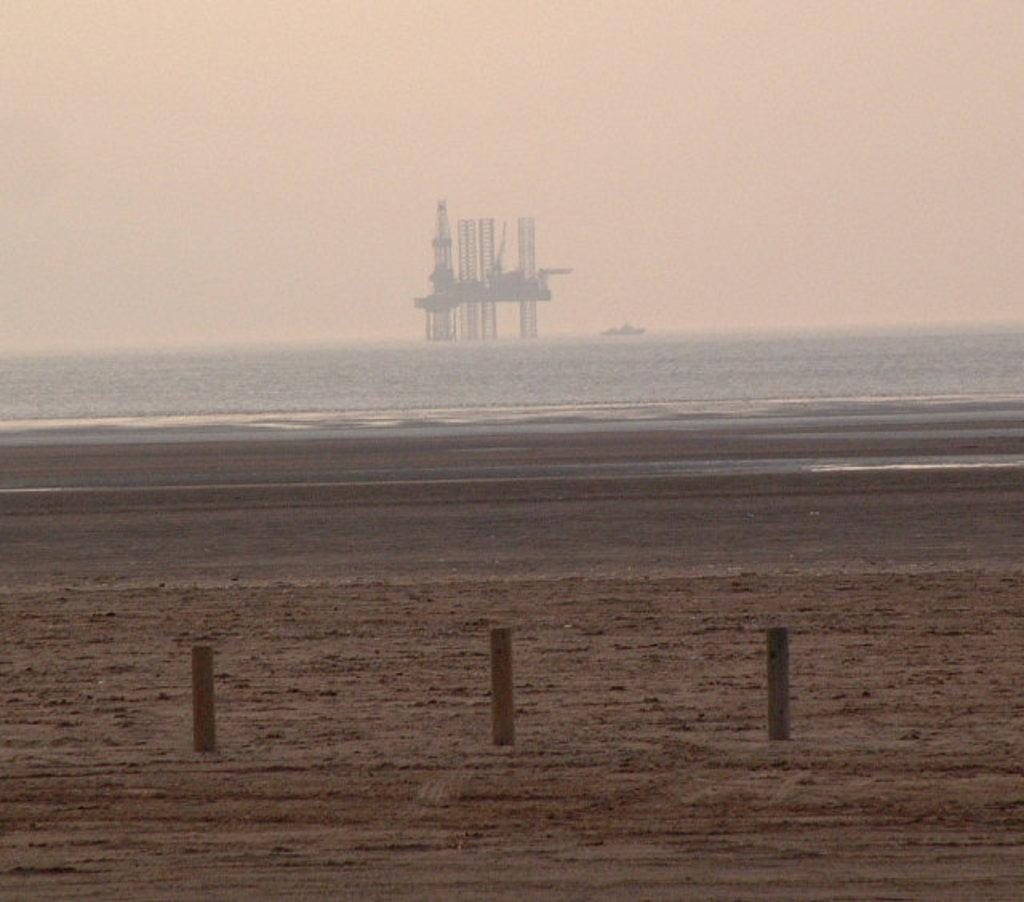What type of surface can be seen in the image? There is ground visible in the image. What structures are present in the image? There are poles in the image. What natural feature is visible in the background of the image? The background of the image includes water. What tall structures can be seen in the distance? There are towers in the background of the image. What part of the sky is visible in the image? The sky is visible in the background of the image. How many boys are standing next to the scarecrow in the image? There is no scarecrow or boys present in the image. 